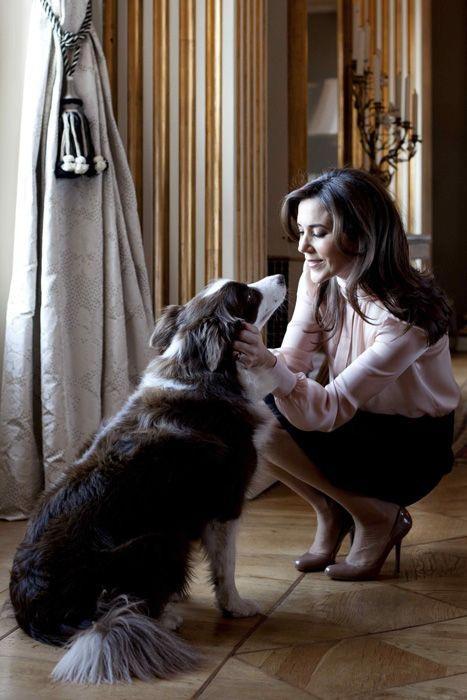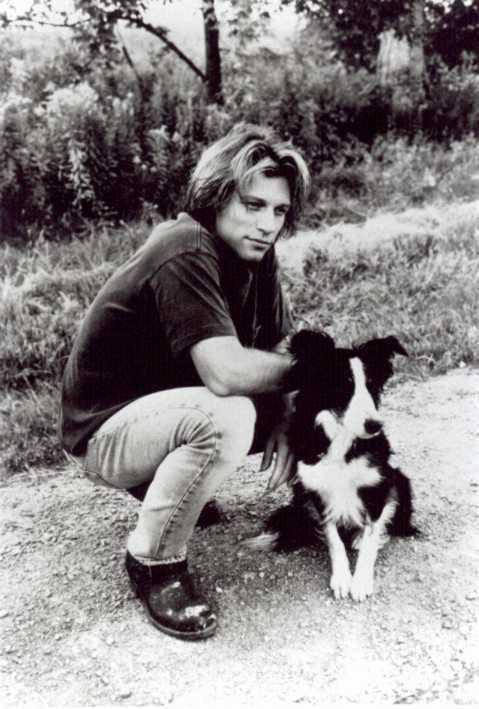The first image is the image on the left, the second image is the image on the right. Evaluate the accuracy of this statement regarding the images: "The right image contains only one human and one dog.". Is it true? Answer yes or no. Yes. The first image is the image on the left, the second image is the image on the right. Assess this claim about the two images: "An image shows a long-haired man in jeans crouching behind a black-and-white dog.". Correct or not? Answer yes or no. Yes. 